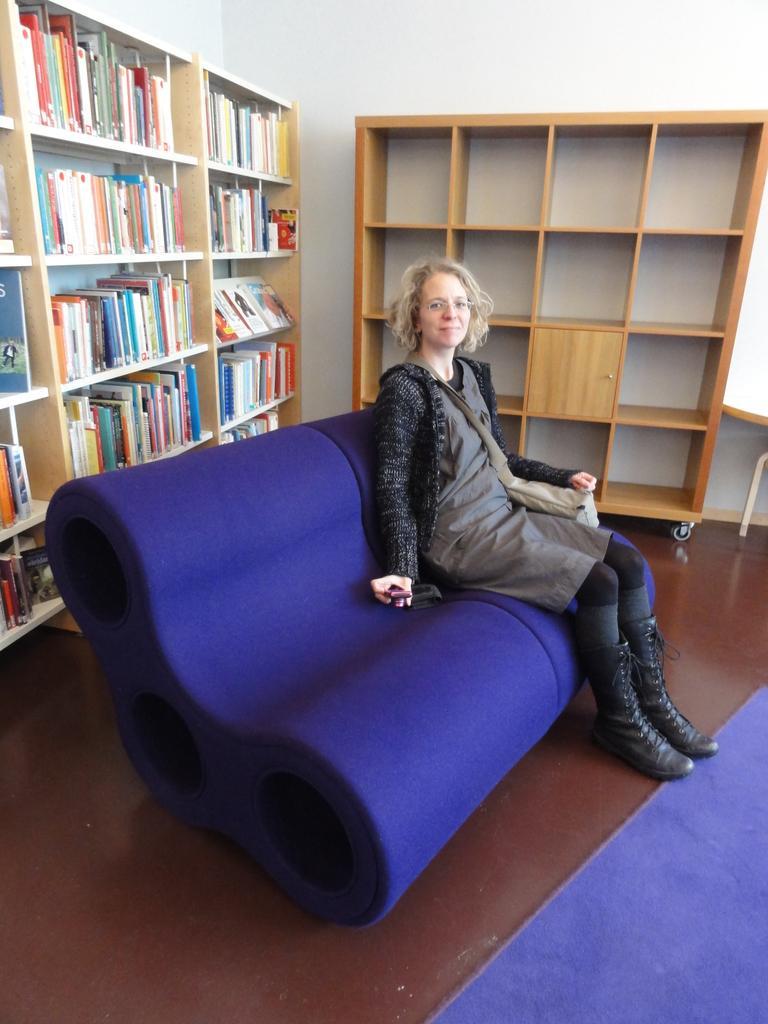How would you summarize this image in a sentence or two? In this image i can see a woman wearing a black dress sitting on the sofa. Behind the woman there is a shelf in which there are couple of books and on the right side of the image we can see an empty shelf. On the floor we can see blue mat and the woman is a spectacles and smiling. 